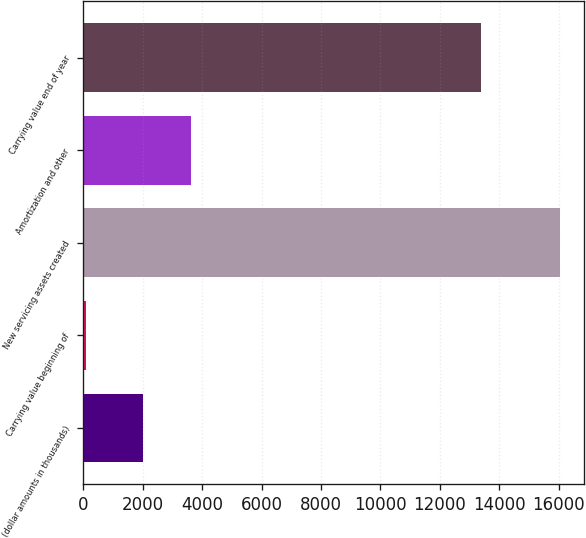Convert chart to OTSL. <chart><loc_0><loc_0><loc_500><loc_500><bar_chart><fcel>(dollar amounts in thousands)<fcel>Carrying value beginning of<fcel>New servicing assets created<fcel>Amortization and other<fcel>Carrying value end of year<nl><fcel>2011<fcel>97<fcel>16039<fcel>3605.2<fcel>13377<nl></chart> 